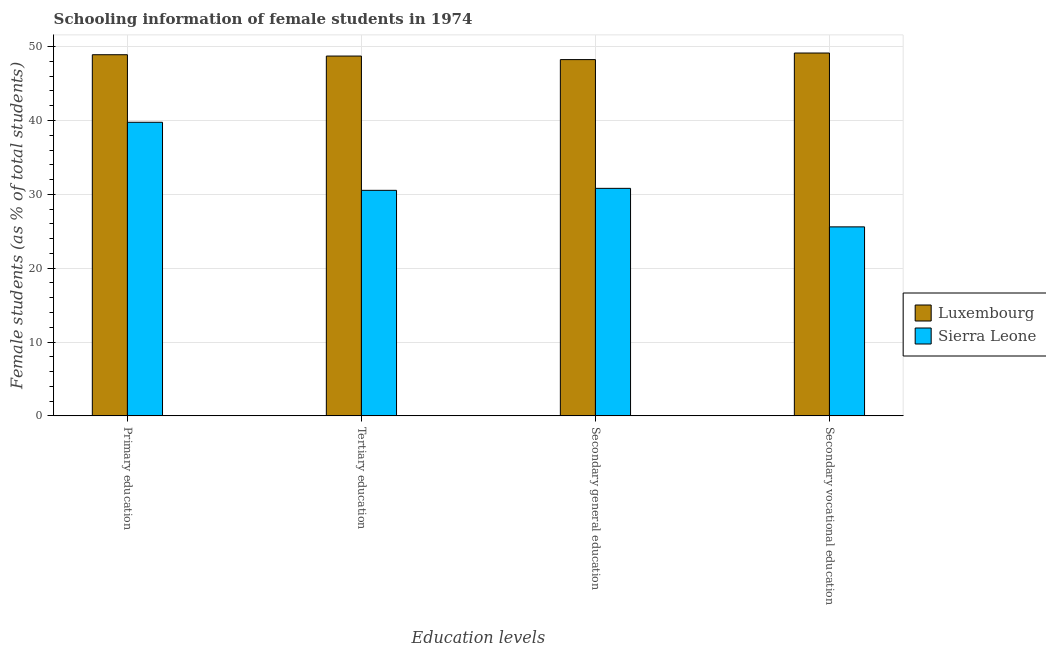How many different coloured bars are there?
Provide a short and direct response. 2. How many groups of bars are there?
Provide a short and direct response. 4. Are the number of bars on each tick of the X-axis equal?
Offer a terse response. Yes. How many bars are there on the 2nd tick from the left?
Keep it short and to the point. 2. What is the label of the 3rd group of bars from the left?
Give a very brief answer. Secondary general education. What is the percentage of female students in secondary vocational education in Sierra Leone?
Your answer should be compact. 25.59. Across all countries, what is the maximum percentage of female students in secondary education?
Keep it short and to the point. 48.24. Across all countries, what is the minimum percentage of female students in secondary vocational education?
Your answer should be very brief. 25.59. In which country was the percentage of female students in secondary education maximum?
Make the answer very short. Luxembourg. In which country was the percentage of female students in tertiary education minimum?
Give a very brief answer. Sierra Leone. What is the total percentage of female students in tertiary education in the graph?
Provide a succinct answer. 79.26. What is the difference between the percentage of female students in tertiary education in Sierra Leone and that in Luxembourg?
Give a very brief answer. -18.18. What is the difference between the percentage of female students in secondary education in Sierra Leone and the percentage of female students in secondary vocational education in Luxembourg?
Offer a very short reply. -18.33. What is the average percentage of female students in tertiary education per country?
Provide a succinct answer. 39.63. What is the difference between the percentage of female students in secondary education and percentage of female students in secondary vocational education in Sierra Leone?
Give a very brief answer. 5.22. In how many countries, is the percentage of female students in primary education greater than 14 %?
Provide a short and direct response. 2. What is the ratio of the percentage of female students in primary education in Sierra Leone to that in Luxembourg?
Make the answer very short. 0.81. What is the difference between the highest and the second highest percentage of female students in secondary education?
Provide a succinct answer. 17.43. What is the difference between the highest and the lowest percentage of female students in secondary education?
Offer a very short reply. 17.43. Is the sum of the percentage of female students in tertiary education in Luxembourg and Sierra Leone greater than the maximum percentage of female students in secondary vocational education across all countries?
Offer a terse response. Yes. Is it the case that in every country, the sum of the percentage of female students in secondary education and percentage of female students in primary education is greater than the sum of percentage of female students in tertiary education and percentage of female students in secondary vocational education?
Your answer should be compact. No. What does the 2nd bar from the left in Tertiary education represents?
Your answer should be compact. Sierra Leone. What does the 1st bar from the right in Secondary vocational education represents?
Your response must be concise. Sierra Leone. How many bars are there?
Provide a succinct answer. 8. How many countries are there in the graph?
Your answer should be compact. 2. What is the difference between two consecutive major ticks on the Y-axis?
Make the answer very short. 10. Does the graph contain grids?
Give a very brief answer. Yes. Where does the legend appear in the graph?
Your response must be concise. Center right. How many legend labels are there?
Your answer should be compact. 2. How are the legend labels stacked?
Keep it short and to the point. Vertical. What is the title of the graph?
Provide a short and direct response. Schooling information of female students in 1974. Does "Kyrgyz Republic" appear as one of the legend labels in the graph?
Your response must be concise. No. What is the label or title of the X-axis?
Provide a succinct answer. Education levels. What is the label or title of the Y-axis?
Provide a short and direct response. Female students (as % of total students). What is the Female students (as % of total students) of Luxembourg in Primary education?
Your response must be concise. 48.9. What is the Female students (as % of total students) in Sierra Leone in Primary education?
Keep it short and to the point. 39.76. What is the Female students (as % of total students) of Luxembourg in Tertiary education?
Your answer should be compact. 48.72. What is the Female students (as % of total students) in Sierra Leone in Tertiary education?
Keep it short and to the point. 30.54. What is the Female students (as % of total students) in Luxembourg in Secondary general education?
Provide a succinct answer. 48.24. What is the Female students (as % of total students) in Sierra Leone in Secondary general education?
Your response must be concise. 30.81. What is the Female students (as % of total students) of Luxembourg in Secondary vocational education?
Make the answer very short. 49.13. What is the Female students (as % of total students) in Sierra Leone in Secondary vocational education?
Offer a terse response. 25.59. Across all Education levels, what is the maximum Female students (as % of total students) in Luxembourg?
Make the answer very short. 49.13. Across all Education levels, what is the maximum Female students (as % of total students) of Sierra Leone?
Keep it short and to the point. 39.76. Across all Education levels, what is the minimum Female students (as % of total students) of Luxembourg?
Ensure brevity in your answer.  48.24. Across all Education levels, what is the minimum Female students (as % of total students) in Sierra Leone?
Give a very brief answer. 25.59. What is the total Female students (as % of total students) of Luxembourg in the graph?
Provide a succinct answer. 195. What is the total Female students (as % of total students) of Sierra Leone in the graph?
Ensure brevity in your answer.  126.69. What is the difference between the Female students (as % of total students) in Luxembourg in Primary education and that in Tertiary education?
Provide a succinct answer. 0.18. What is the difference between the Female students (as % of total students) of Sierra Leone in Primary education and that in Tertiary education?
Offer a very short reply. 9.22. What is the difference between the Female students (as % of total students) of Luxembourg in Primary education and that in Secondary general education?
Offer a terse response. 0.66. What is the difference between the Female students (as % of total students) in Sierra Leone in Primary education and that in Secondary general education?
Offer a very short reply. 8.95. What is the difference between the Female students (as % of total students) of Luxembourg in Primary education and that in Secondary vocational education?
Your answer should be compact. -0.23. What is the difference between the Female students (as % of total students) in Sierra Leone in Primary education and that in Secondary vocational education?
Your answer should be very brief. 14.16. What is the difference between the Female students (as % of total students) in Luxembourg in Tertiary education and that in Secondary general education?
Make the answer very short. 0.48. What is the difference between the Female students (as % of total students) in Sierra Leone in Tertiary education and that in Secondary general education?
Provide a succinct answer. -0.27. What is the difference between the Female students (as % of total students) in Luxembourg in Tertiary education and that in Secondary vocational education?
Your answer should be compact. -0.41. What is the difference between the Female students (as % of total students) of Sierra Leone in Tertiary education and that in Secondary vocational education?
Provide a succinct answer. 4.95. What is the difference between the Female students (as % of total students) in Luxembourg in Secondary general education and that in Secondary vocational education?
Your response must be concise. -0.89. What is the difference between the Female students (as % of total students) in Sierra Leone in Secondary general education and that in Secondary vocational education?
Your response must be concise. 5.22. What is the difference between the Female students (as % of total students) of Luxembourg in Primary education and the Female students (as % of total students) of Sierra Leone in Tertiary education?
Offer a terse response. 18.36. What is the difference between the Female students (as % of total students) in Luxembourg in Primary education and the Female students (as % of total students) in Sierra Leone in Secondary general education?
Provide a succinct answer. 18.09. What is the difference between the Female students (as % of total students) of Luxembourg in Primary education and the Female students (as % of total students) of Sierra Leone in Secondary vocational education?
Offer a very short reply. 23.31. What is the difference between the Female students (as % of total students) in Luxembourg in Tertiary education and the Female students (as % of total students) in Sierra Leone in Secondary general education?
Offer a terse response. 17.91. What is the difference between the Female students (as % of total students) of Luxembourg in Tertiary education and the Female students (as % of total students) of Sierra Leone in Secondary vocational education?
Offer a terse response. 23.13. What is the difference between the Female students (as % of total students) in Luxembourg in Secondary general education and the Female students (as % of total students) in Sierra Leone in Secondary vocational education?
Ensure brevity in your answer.  22.65. What is the average Female students (as % of total students) in Luxembourg per Education levels?
Your response must be concise. 48.75. What is the average Female students (as % of total students) in Sierra Leone per Education levels?
Provide a succinct answer. 31.67. What is the difference between the Female students (as % of total students) in Luxembourg and Female students (as % of total students) in Sierra Leone in Primary education?
Give a very brief answer. 9.15. What is the difference between the Female students (as % of total students) in Luxembourg and Female students (as % of total students) in Sierra Leone in Tertiary education?
Give a very brief answer. 18.18. What is the difference between the Female students (as % of total students) in Luxembourg and Female students (as % of total students) in Sierra Leone in Secondary general education?
Your answer should be very brief. 17.43. What is the difference between the Female students (as % of total students) in Luxembourg and Female students (as % of total students) in Sierra Leone in Secondary vocational education?
Provide a succinct answer. 23.54. What is the ratio of the Female students (as % of total students) of Sierra Leone in Primary education to that in Tertiary education?
Give a very brief answer. 1.3. What is the ratio of the Female students (as % of total students) in Luxembourg in Primary education to that in Secondary general education?
Make the answer very short. 1.01. What is the ratio of the Female students (as % of total students) in Sierra Leone in Primary education to that in Secondary general education?
Keep it short and to the point. 1.29. What is the ratio of the Female students (as % of total students) of Sierra Leone in Primary education to that in Secondary vocational education?
Your answer should be compact. 1.55. What is the ratio of the Female students (as % of total students) of Luxembourg in Tertiary education to that in Secondary general education?
Provide a succinct answer. 1.01. What is the ratio of the Female students (as % of total students) of Luxembourg in Tertiary education to that in Secondary vocational education?
Give a very brief answer. 0.99. What is the ratio of the Female students (as % of total students) in Sierra Leone in Tertiary education to that in Secondary vocational education?
Your response must be concise. 1.19. What is the ratio of the Female students (as % of total students) of Luxembourg in Secondary general education to that in Secondary vocational education?
Offer a terse response. 0.98. What is the ratio of the Female students (as % of total students) in Sierra Leone in Secondary general education to that in Secondary vocational education?
Your answer should be compact. 1.2. What is the difference between the highest and the second highest Female students (as % of total students) in Luxembourg?
Offer a very short reply. 0.23. What is the difference between the highest and the second highest Female students (as % of total students) in Sierra Leone?
Make the answer very short. 8.95. What is the difference between the highest and the lowest Female students (as % of total students) in Luxembourg?
Ensure brevity in your answer.  0.89. What is the difference between the highest and the lowest Female students (as % of total students) in Sierra Leone?
Your response must be concise. 14.16. 